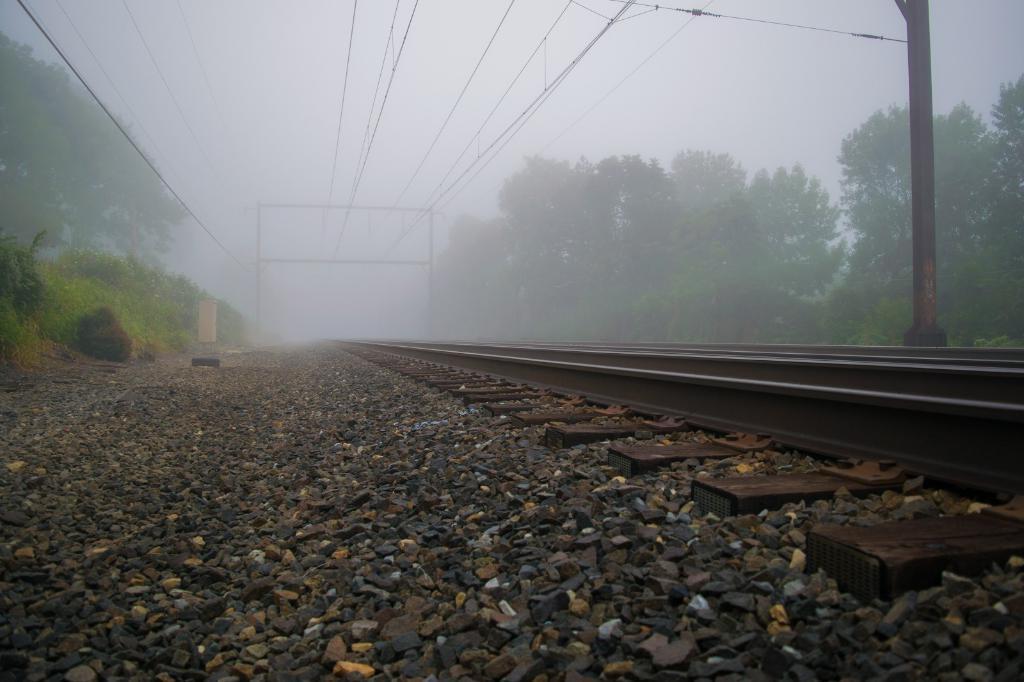Please provide a concise description of this image. In this picture I can observe a railway track. There are some stones on the land. On the right side there is a pole. I can observe wires in this picture. On either sides of the track there are trees. In the background there is a fog. 